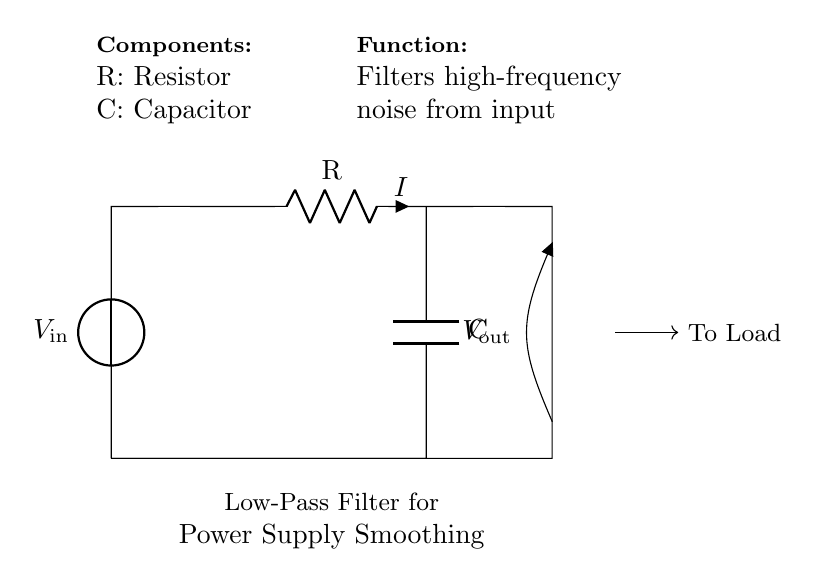What is the function of the capacitor in this circuit? The capacitor functions to filter out high-frequency noise from the input voltage, allowing only low-frequency signals to pass through. This smoothing effect stabilizes the power supply output for the load.
Answer: Filter high-frequency noise What is the value of the input voltage represented in the circuit? The input voltage is denoted as V in the circuit diagram. There is no specific numerical value given directly; it is a placeholder for any input voltage that can be connected.
Answer: V_in What components are present in this low-pass filter circuit? The components in the circuit include a resistor (R) and a capacitor (C), both linked in a series arrangement. The resistor limits current flow while the capacitor smooths voltage fluctuations.
Answer: Resistor and Capacitor What is the output voltage connected to in this circuit? The output voltage (V_out) is taken across the capacitor and denoted at the output terminal, which connects to the load. This represents the voltage that is smoothed by the filter action of the capacitor.
Answer: V_out How does the resistance value influence the filter's behavior? The resistance value affects the cutoff frequency of the low-pass filter. A higher resistance increases filtering, reducing high-frequency noise but may also slow down the response time of the circuit.
Answer: Cutoff frequency Which direction does the current flow in this circuit? Current flows from the voltage source through the resistor, into the capacitor, and then to the output. The circuit's design allows the current to follow this path based on the connections made.
Answer: From V_in to V_out 